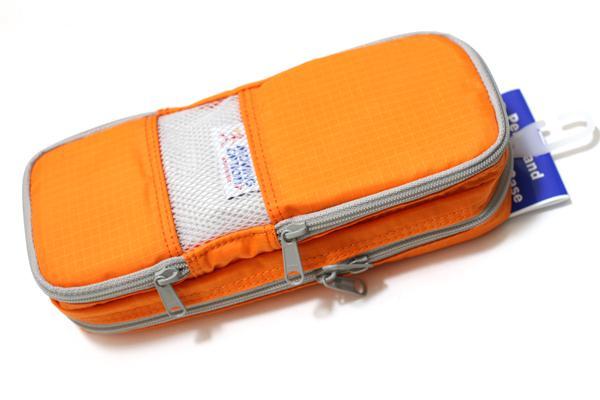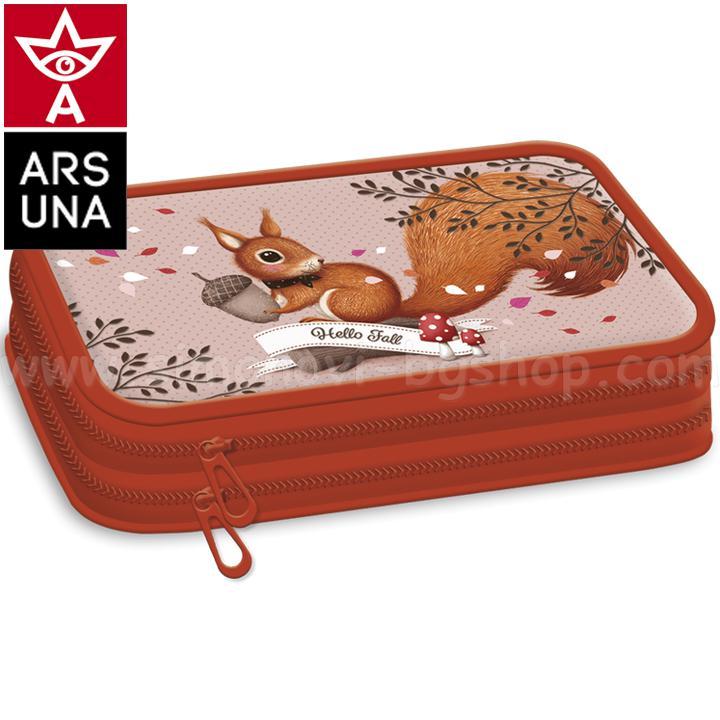The first image is the image on the left, the second image is the image on the right. For the images displayed, is the sentence "Each image contains a single closed pencil case, and at least one case is a solid color with contrasting zipper." factually correct? Answer yes or no. Yes. 